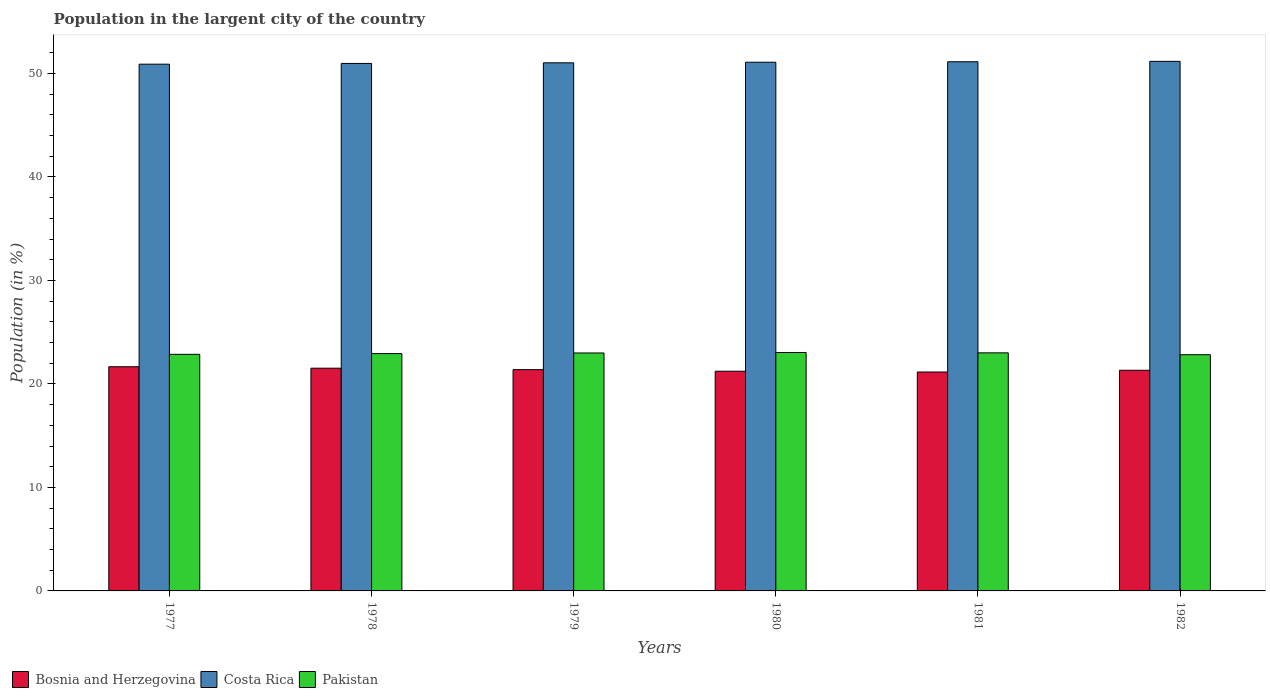How many groups of bars are there?
Your answer should be very brief. 6. Are the number of bars per tick equal to the number of legend labels?
Provide a short and direct response. Yes. Are the number of bars on each tick of the X-axis equal?
Make the answer very short. Yes. What is the label of the 4th group of bars from the left?
Your answer should be compact. 1980. In how many cases, is the number of bars for a given year not equal to the number of legend labels?
Offer a terse response. 0. What is the percentage of population in the largent city in Costa Rica in 1982?
Offer a terse response. 51.17. Across all years, what is the maximum percentage of population in the largent city in Bosnia and Herzegovina?
Keep it short and to the point. 21.66. Across all years, what is the minimum percentage of population in the largent city in Pakistan?
Provide a succinct answer. 22.82. In which year was the percentage of population in the largent city in Bosnia and Herzegovina maximum?
Make the answer very short. 1977. What is the total percentage of population in the largent city in Bosnia and Herzegovina in the graph?
Ensure brevity in your answer.  128.25. What is the difference between the percentage of population in the largent city in Pakistan in 1977 and that in 1981?
Offer a very short reply. -0.14. What is the difference between the percentage of population in the largent city in Pakistan in 1977 and the percentage of population in the largent city in Bosnia and Herzegovina in 1980?
Give a very brief answer. 1.63. What is the average percentage of population in the largent city in Pakistan per year?
Make the answer very short. 22.94. In the year 1978, what is the difference between the percentage of population in the largent city in Pakistan and percentage of population in the largent city in Costa Rica?
Offer a very short reply. -28.03. In how many years, is the percentage of population in the largent city in Pakistan greater than 20 %?
Ensure brevity in your answer.  6. What is the ratio of the percentage of population in the largent city in Costa Rica in 1977 to that in 1979?
Provide a succinct answer. 1. Is the difference between the percentage of population in the largent city in Pakistan in 1977 and 1981 greater than the difference between the percentage of population in the largent city in Costa Rica in 1977 and 1981?
Offer a terse response. Yes. What is the difference between the highest and the second highest percentage of population in the largent city in Costa Rica?
Keep it short and to the point. 0.04. What is the difference between the highest and the lowest percentage of population in the largent city in Pakistan?
Make the answer very short. 0.21. In how many years, is the percentage of population in the largent city in Pakistan greater than the average percentage of population in the largent city in Pakistan taken over all years?
Give a very brief answer. 3. Is the sum of the percentage of population in the largent city in Costa Rica in 1977 and 1981 greater than the maximum percentage of population in the largent city in Bosnia and Herzegovina across all years?
Your response must be concise. Yes. What does the 3rd bar from the left in 1977 represents?
Offer a very short reply. Pakistan. What does the 3rd bar from the right in 1980 represents?
Ensure brevity in your answer.  Bosnia and Herzegovina. How many bars are there?
Offer a terse response. 18. Are all the bars in the graph horizontal?
Your answer should be very brief. No. How many years are there in the graph?
Your answer should be very brief. 6. Are the values on the major ticks of Y-axis written in scientific E-notation?
Offer a very short reply. No. Does the graph contain any zero values?
Your response must be concise. No. Where does the legend appear in the graph?
Offer a terse response. Bottom left. What is the title of the graph?
Give a very brief answer. Population in the largent city of the country. What is the label or title of the X-axis?
Your answer should be very brief. Years. What is the label or title of the Y-axis?
Ensure brevity in your answer.  Population (in %). What is the Population (in %) in Bosnia and Herzegovina in 1977?
Your answer should be compact. 21.66. What is the Population (in %) of Costa Rica in 1977?
Offer a very short reply. 50.89. What is the Population (in %) in Pakistan in 1977?
Your response must be concise. 22.86. What is the Population (in %) in Bosnia and Herzegovina in 1978?
Provide a succinct answer. 21.52. What is the Population (in %) of Costa Rica in 1978?
Offer a very short reply. 50.96. What is the Population (in %) of Pakistan in 1978?
Offer a very short reply. 22.93. What is the Population (in %) in Bosnia and Herzegovina in 1979?
Your answer should be very brief. 21.38. What is the Population (in %) of Costa Rica in 1979?
Ensure brevity in your answer.  51.02. What is the Population (in %) in Pakistan in 1979?
Ensure brevity in your answer.  22.99. What is the Population (in %) of Bosnia and Herzegovina in 1980?
Offer a terse response. 21.23. What is the Population (in %) in Costa Rica in 1980?
Your answer should be compact. 51.08. What is the Population (in %) of Pakistan in 1980?
Your answer should be very brief. 23.04. What is the Population (in %) in Bosnia and Herzegovina in 1981?
Provide a short and direct response. 21.15. What is the Population (in %) of Costa Rica in 1981?
Offer a very short reply. 51.13. What is the Population (in %) of Pakistan in 1981?
Your answer should be very brief. 23. What is the Population (in %) in Bosnia and Herzegovina in 1982?
Your answer should be compact. 21.32. What is the Population (in %) of Costa Rica in 1982?
Provide a short and direct response. 51.17. What is the Population (in %) in Pakistan in 1982?
Give a very brief answer. 22.82. Across all years, what is the maximum Population (in %) in Bosnia and Herzegovina?
Keep it short and to the point. 21.66. Across all years, what is the maximum Population (in %) in Costa Rica?
Make the answer very short. 51.17. Across all years, what is the maximum Population (in %) in Pakistan?
Make the answer very short. 23.04. Across all years, what is the minimum Population (in %) of Bosnia and Herzegovina?
Keep it short and to the point. 21.15. Across all years, what is the minimum Population (in %) of Costa Rica?
Give a very brief answer. 50.89. Across all years, what is the minimum Population (in %) of Pakistan?
Give a very brief answer. 22.82. What is the total Population (in %) in Bosnia and Herzegovina in the graph?
Offer a very short reply. 128.25. What is the total Population (in %) of Costa Rica in the graph?
Provide a succinct answer. 306.25. What is the total Population (in %) in Pakistan in the graph?
Keep it short and to the point. 137.64. What is the difference between the Population (in %) of Bosnia and Herzegovina in 1977 and that in 1978?
Make the answer very short. 0.14. What is the difference between the Population (in %) in Costa Rica in 1977 and that in 1978?
Your answer should be very brief. -0.07. What is the difference between the Population (in %) of Pakistan in 1977 and that in 1978?
Ensure brevity in your answer.  -0.07. What is the difference between the Population (in %) in Bosnia and Herzegovina in 1977 and that in 1979?
Keep it short and to the point. 0.28. What is the difference between the Population (in %) in Costa Rica in 1977 and that in 1979?
Ensure brevity in your answer.  -0.13. What is the difference between the Population (in %) in Pakistan in 1977 and that in 1979?
Ensure brevity in your answer.  -0.13. What is the difference between the Population (in %) of Bosnia and Herzegovina in 1977 and that in 1980?
Your answer should be very brief. 0.43. What is the difference between the Population (in %) in Costa Rica in 1977 and that in 1980?
Ensure brevity in your answer.  -0.19. What is the difference between the Population (in %) in Pakistan in 1977 and that in 1980?
Keep it short and to the point. -0.18. What is the difference between the Population (in %) of Bosnia and Herzegovina in 1977 and that in 1981?
Provide a succinct answer. 0.51. What is the difference between the Population (in %) in Costa Rica in 1977 and that in 1981?
Offer a terse response. -0.23. What is the difference between the Population (in %) in Pakistan in 1977 and that in 1981?
Make the answer very short. -0.14. What is the difference between the Population (in %) of Bosnia and Herzegovina in 1977 and that in 1982?
Your response must be concise. 0.34. What is the difference between the Population (in %) in Costa Rica in 1977 and that in 1982?
Your answer should be very brief. -0.27. What is the difference between the Population (in %) of Pakistan in 1977 and that in 1982?
Offer a very short reply. 0.04. What is the difference between the Population (in %) in Bosnia and Herzegovina in 1978 and that in 1979?
Your answer should be very brief. 0.14. What is the difference between the Population (in %) in Costa Rica in 1978 and that in 1979?
Your answer should be very brief. -0.06. What is the difference between the Population (in %) of Pakistan in 1978 and that in 1979?
Provide a succinct answer. -0.06. What is the difference between the Population (in %) of Bosnia and Herzegovina in 1978 and that in 1980?
Make the answer very short. 0.29. What is the difference between the Population (in %) of Costa Rica in 1978 and that in 1980?
Ensure brevity in your answer.  -0.12. What is the difference between the Population (in %) of Pakistan in 1978 and that in 1980?
Ensure brevity in your answer.  -0.11. What is the difference between the Population (in %) of Bosnia and Herzegovina in 1978 and that in 1981?
Provide a succinct answer. 0.37. What is the difference between the Population (in %) of Costa Rica in 1978 and that in 1981?
Make the answer very short. -0.16. What is the difference between the Population (in %) in Pakistan in 1978 and that in 1981?
Your answer should be very brief. -0.07. What is the difference between the Population (in %) in Bosnia and Herzegovina in 1978 and that in 1982?
Your response must be concise. 0.2. What is the difference between the Population (in %) of Costa Rica in 1978 and that in 1982?
Provide a succinct answer. -0.2. What is the difference between the Population (in %) of Pakistan in 1978 and that in 1982?
Your answer should be compact. 0.11. What is the difference between the Population (in %) of Bosnia and Herzegovina in 1979 and that in 1980?
Provide a short and direct response. 0.15. What is the difference between the Population (in %) of Costa Rica in 1979 and that in 1980?
Offer a very short reply. -0.06. What is the difference between the Population (in %) in Pakistan in 1979 and that in 1980?
Your response must be concise. -0.05. What is the difference between the Population (in %) in Bosnia and Herzegovina in 1979 and that in 1981?
Your answer should be compact. 0.23. What is the difference between the Population (in %) of Costa Rica in 1979 and that in 1981?
Give a very brief answer. -0.1. What is the difference between the Population (in %) in Pakistan in 1979 and that in 1981?
Ensure brevity in your answer.  -0.01. What is the difference between the Population (in %) of Bosnia and Herzegovina in 1979 and that in 1982?
Ensure brevity in your answer.  0.06. What is the difference between the Population (in %) in Costa Rica in 1979 and that in 1982?
Provide a short and direct response. -0.14. What is the difference between the Population (in %) of Pakistan in 1979 and that in 1982?
Offer a very short reply. 0.17. What is the difference between the Population (in %) of Bosnia and Herzegovina in 1980 and that in 1981?
Your response must be concise. 0.07. What is the difference between the Population (in %) in Costa Rica in 1980 and that in 1981?
Your answer should be very brief. -0.05. What is the difference between the Population (in %) of Pakistan in 1980 and that in 1981?
Keep it short and to the point. 0.04. What is the difference between the Population (in %) in Bosnia and Herzegovina in 1980 and that in 1982?
Keep it short and to the point. -0.09. What is the difference between the Population (in %) in Costa Rica in 1980 and that in 1982?
Keep it short and to the point. -0.08. What is the difference between the Population (in %) in Pakistan in 1980 and that in 1982?
Offer a very short reply. 0.21. What is the difference between the Population (in %) in Bosnia and Herzegovina in 1981 and that in 1982?
Provide a short and direct response. -0.17. What is the difference between the Population (in %) of Costa Rica in 1981 and that in 1982?
Make the answer very short. -0.04. What is the difference between the Population (in %) of Pakistan in 1981 and that in 1982?
Provide a succinct answer. 0.18. What is the difference between the Population (in %) in Bosnia and Herzegovina in 1977 and the Population (in %) in Costa Rica in 1978?
Give a very brief answer. -29.3. What is the difference between the Population (in %) of Bosnia and Herzegovina in 1977 and the Population (in %) of Pakistan in 1978?
Give a very brief answer. -1.27. What is the difference between the Population (in %) in Costa Rica in 1977 and the Population (in %) in Pakistan in 1978?
Provide a short and direct response. 27.96. What is the difference between the Population (in %) in Bosnia and Herzegovina in 1977 and the Population (in %) in Costa Rica in 1979?
Provide a short and direct response. -29.36. What is the difference between the Population (in %) of Bosnia and Herzegovina in 1977 and the Population (in %) of Pakistan in 1979?
Ensure brevity in your answer.  -1.33. What is the difference between the Population (in %) of Costa Rica in 1977 and the Population (in %) of Pakistan in 1979?
Offer a very short reply. 27.9. What is the difference between the Population (in %) of Bosnia and Herzegovina in 1977 and the Population (in %) of Costa Rica in 1980?
Your answer should be very brief. -29.42. What is the difference between the Population (in %) of Bosnia and Herzegovina in 1977 and the Population (in %) of Pakistan in 1980?
Offer a terse response. -1.38. What is the difference between the Population (in %) in Costa Rica in 1977 and the Population (in %) in Pakistan in 1980?
Make the answer very short. 27.86. What is the difference between the Population (in %) in Bosnia and Herzegovina in 1977 and the Population (in %) in Costa Rica in 1981?
Provide a succinct answer. -29.47. What is the difference between the Population (in %) of Bosnia and Herzegovina in 1977 and the Population (in %) of Pakistan in 1981?
Your response must be concise. -1.34. What is the difference between the Population (in %) of Costa Rica in 1977 and the Population (in %) of Pakistan in 1981?
Offer a terse response. 27.89. What is the difference between the Population (in %) in Bosnia and Herzegovina in 1977 and the Population (in %) in Costa Rica in 1982?
Your response must be concise. -29.51. What is the difference between the Population (in %) in Bosnia and Herzegovina in 1977 and the Population (in %) in Pakistan in 1982?
Your answer should be compact. -1.16. What is the difference between the Population (in %) of Costa Rica in 1977 and the Population (in %) of Pakistan in 1982?
Your response must be concise. 28.07. What is the difference between the Population (in %) in Bosnia and Herzegovina in 1978 and the Population (in %) in Costa Rica in 1979?
Provide a succinct answer. -29.51. What is the difference between the Population (in %) in Bosnia and Herzegovina in 1978 and the Population (in %) in Pakistan in 1979?
Ensure brevity in your answer.  -1.47. What is the difference between the Population (in %) of Costa Rica in 1978 and the Population (in %) of Pakistan in 1979?
Your response must be concise. 27.97. What is the difference between the Population (in %) of Bosnia and Herzegovina in 1978 and the Population (in %) of Costa Rica in 1980?
Your response must be concise. -29.56. What is the difference between the Population (in %) in Bosnia and Herzegovina in 1978 and the Population (in %) in Pakistan in 1980?
Offer a very short reply. -1.52. What is the difference between the Population (in %) in Costa Rica in 1978 and the Population (in %) in Pakistan in 1980?
Provide a short and direct response. 27.93. What is the difference between the Population (in %) in Bosnia and Herzegovina in 1978 and the Population (in %) in Costa Rica in 1981?
Keep it short and to the point. -29.61. What is the difference between the Population (in %) in Bosnia and Herzegovina in 1978 and the Population (in %) in Pakistan in 1981?
Make the answer very short. -1.48. What is the difference between the Population (in %) in Costa Rica in 1978 and the Population (in %) in Pakistan in 1981?
Your response must be concise. 27.96. What is the difference between the Population (in %) of Bosnia and Herzegovina in 1978 and the Population (in %) of Costa Rica in 1982?
Your response must be concise. -29.65. What is the difference between the Population (in %) of Bosnia and Herzegovina in 1978 and the Population (in %) of Pakistan in 1982?
Your answer should be compact. -1.3. What is the difference between the Population (in %) of Costa Rica in 1978 and the Population (in %) of Pakistan in 1982?
Your answer should be compact. 28.14. What is the difference between the Population (in %) in Bosnia and Herzegovina in 1979 and the Population (in %) in Costa Rica in 1980?
Your answer should be compact. -29.7. What is the difference between the Population (in %) in Bosnia and Herzegovina in 1979 and the Population (in %) in Pakistan in 1980?
Make the answer very short. -1.66. What is the difference between the Population (in %) in Costa Rica in 1979 and the Population (in %) in Pakistan in 1980?
Your answer should be compact. 27.99. What is the difference between the Population (in %) in Bosnia and Herzegovina in 1979 and the Population (in %) in Costa Rica in 1981?
Provide a short and direct response. -29.75. What is the difference between the Population (in %) of Bosnia and Herzegovina in 1979 and the Population (in %) of Pakistan in 1981?
Keep it short and to the point. -1.62. What is the difference between the Population (in %) in Costa Rica in 1979 and the Population (in %) in Pakistan in 1981?
Offer a very short reply. 28.02. What is the difference between the Population (in %) in Bosnia and Herzegovina in 1979 and the Population (in %) in Costa Rica in 1982?
Offer a very short reply. -29.79. What is the difference between the Population (in %) of Bosnia and Herzegovina in 1979 and the Population (in %) of Pakistan in 1982?
Your answer should be compact. -1.44. What is the difference between the Population (in %) in Costa Rica in 1979 and the Population (in %) in Pakistan in 1982?
Keep it short and to the point. 28.2. What is the difference between the Population (in %) in Bosnia and Herzegovina in 1980 and the Population (in %) in Costa Rica in 1981?
Keep it short and to the point. -29.9. What is the difference between the Population (in %) in Bosnia and Herzegovina in 1980 and the Population (in %) in Pakistan in 1981?
Your answer should be compact. -1.78. What is the difference between the Population (in %) of Costa Rica in 1980 and the Population (in %) of Pakistan in 1981?
Your response must be concise. 28.08. What is the difference between the Population (in %) in Bosnia and Herzegovina in 1980 and the Population (in %) in Costa Rica in 1982?
Keep it short and to the point. -29.94. What is the difference between the Population (in %) of Bosnia and Herzegovina in 1980 and the Population (in %) of Pakistan in 1982?
Offer a very short reply. -1.6. What is the difference between the Population (in %) of Costa Rica in 1980 and the Population (in %) of Pakistan in 1982?
Give a very brief answer. 28.26. What is the difference between the Population (in %) in Bosnia and Herzegovina in 1981 and the Population (in %) in Costa Rica in 1982?
Provide a succinct answer. -30.01. What is the difference between the Population (in %) in Bosnia and Herzegovina in 1981 and the Population (in %) in Pakistan in 1982?
Provide a short and direct response. -1.67. What is the difference between the Population (in %) of Costa Rica in 1981 and the Population (in %) of Pakistan in 1982?
Your response must be concise. 28.3. What is the average Population (in %) in Bosnia and Herzegovina per year?
Provide a succinct answer. 21.38. What is the average Population (in %) in Costa Rica per year?
Provide a succinct answer. 51.04. What is the average Population (in %) in Pakistan per year?
Your response must be concise. 22.94. In the year 1977, what is the difference between the Population (in %) in Bosnia and Herzegovina and Population (in %) in Costa Rica?
Your response must be concise. -29.23. In the year 1977, what is the difference between the Population (in %) of Bosnia and Herzegovina and Population (in %) of Pakistan?
Provide a short and direct response. -1.2. In the year 1977, what is the difference between the Population (in %) of Costa Rica and Population (in %) of Pakistan?
Make the answer very short. 28.03. In the year 1978, what is the difference between the Population (in %) in Bosnia and Herzegovina and Population (in %) in Costa Rica?
Offer a terse response. -29.44. In the year 1978, what is the difference between the Population (in %) in Bosnia and Herzegovina and Population (in %) in Pakistan?
Keep it short and to the point. -1.41. In the year 1978, what is the difference between the Population (in %) in Costa Rica and Population (in %) in Pakistan?
Offer a terse response. 28.03. In the year 1979, what is the difference between the Population (in %) in Bosnia and Herzegovina and Population (in %) in Costa Rica?
Give a very brief answer. -29.65. In the year 1979, what is the difference between the Population (in %) of Bosnia and Herzegovina and Population (in %) of Pakistan?
Make the answer very short. -1.61. In the year 1979, what is the difference between the Population (in %) of Costa Rica and Population (in %) of Pakistan?
Ensure brevity in your answer.  28.03. In the year 1980, what is the difference between the Population (in %) in Bosnia and Herzegovina and Population (in %) in Costa Rica?
Your answer should be compact. -29.86. In the year 1980, what is the difference between the Population (in %) of Bosnia and Herzegovina and Population (in %) of Pakistan?
Provide a succinct answer. -1.81. In the year 1980, what is the difference between the Population (in %) of Costa Rica and Population (in %) of Pakistan?
Your response must be concise. 28.04. In the year 1981, what is the difference between the Population (in %) in Bosnia and Herzegovina and Population (in %) in Costa Rica?
Give a very brief answer. -29.98. In the year 1981, what is the difference between the Population (in %) of Bosnia and Herzegovina and Population (in %) of Pakistan?
Offer a terse response. -1.85. In the year 1981, what is the difference between the Population (in %) in Costa Rica and Population (in %) in Pakistan?
Ensure brevity in your answer.  28.12. In the year 1982, what is the difference between the Population (in %) of Bosnia and Herzegovina and Population (in %) of Costa Rica?
Your answer should be very brief. -29.85. In the year 1982, what is the difference between the Population (in %) in Bosnia and Herzegovina and Population (in %) in Pakistan?
Offer a terse response. -1.5. In the year 1982, what is the difference between the Population (in %) of Costa Rica and Population (in %) of Pakistan?
Your answer should be very brief. 28.34. What is the ratio of the Population (in %) of Bosnia and Herzegovina in 1977 to that in 1978?
Ensure brevity in your answer.  1.01. What is the ratio of the Population (in %) in Bosnia and Herzegovina in 1977 to that in 1979?
Ensure brevity in your answer.  1.01. What is the ratio of the Population (in %) in Costa Rica in 1977 to that in 1979?
Provide a succinct answer. 1. What is the ratio of the Population (in %) of Pakistan in 1977 to that in 1979?
Your answer should be very brief. 0.99. What is the ratio of the Population (in %) of Bosnia and Herzegovina in 1977 to that in 1980?
Ensure brevity in your answer.  1.02. What is the ratio of the Population (in %) in Costa Rica in 1977 to that in 1980?
Provide a short and direct response. 1. What is the ratio of the Population (in %) in Pakistan in 1977 to that in 1980?
Your answer should be very brief. 0.99. What is the ratio of the Population (in %) in Bosnia and Herzegovina in 1977 to that in 1981?
Offer a terse response. 1.02. What is the ratio of the Population (in %) in Pakistan in 1977 to that in 1981?
Give a very brief answer. 0.99. What is the ratio of the Population (in %) of Pakistan in 1977 to that in 1982?
Ensure brevity in your answer.  1. What is the ratio of the Population (in %) of Bosnia and Herzegovina in 1978 to that in 1979?
Offer a very short reply. 1.01. What is the ratio of the Population (in %) of Costa Rica in 1978 to that in 1979?
Provide a short and direct response. 1. What is the ratio of the Population (in %) in Bosnia and Herzegovina in 1978 to that in 1980?
Provide a succinct answer. 1.01. What is the ratio of the Population (in %) of Costa Rica in 1978 to that in 1980?
Ensure brevity in your answer.  1. What is the ratio of the Population (in %) of Pakistan in 1978 to that in 1980?
Keep it short and to the point. 1. What is the ratio of the Population (in %) of Bosnia and Herzegovina in 1978 to that in 1981?
Offer a terse response. 1.02. What is the ratio of the Population (in %) in Costa Rica in 1978 to that in 1981?
Your response must be concise. 1. What is the ratio of the Population (in %) in Bosnia and Herzegovina in 1978 to that in 1982?
Provide a short and direct response. 1.01. What is the ratio of the Population (in %) of Costa Rica in 1979 to that in 1980?
Offer a very short reply. 1. What is the ratio of the Population (in %) of Bosnia and Herzegovina in 1979 to that in 1981?
Provide a short and direct response. 1.01. What is the ratio of the Population (in %) in Bosnia and Herzegovina in 1979 to that in 1982?
Make the answer very short. 1. What is the ratio of the Population (in %) of Costa Rica in 1979 to that in 1982?
Keep it short and to the point. 1. What is the ratio of the Population (in %) of Pakistan in 1979 to that in 1982?
Offer a terse response. 1.01. What is the ratio of the Population (in %) of Costa Rica in 1980 to that in 1981?
Ensure brevity in your answer.  1. What is the ratio of the Population (in %) of Pakistan in 1980 to that in 1981?
Make the answer very short. 1. What is the ratio of the Population (in %) of Bosnia and Herzegovina in 1980 to that in 1982?
Offer a very short reply. 1. What is the ratio of the Population (in %) in Costa Rica in 1980 to that in 1982?
Your response must be concise. 1. What is the ratio of the Population (in %) in Pakistan in 1980 to that in 1982?
Provide a short and direct response. 1.01. What is the ratio of the Population (in %) of Costa Rica in 1981 to that in 1982?
Your response must be concise. 1. What is the ratio of the Population (in %) in Pakistan in 1981 to that in 1982?
Your answer should be very brief. 1.01. What is the difference between the highest and the second highest Population (in %) in Bosnia and Herzegovina?
Make the answer very short. 0.14. What is the difference between the highest and the second highest Population (in %) of Costa Rica?
Keep it short and to the point. 0.04. What is the difference between the highest and the second highest Population (in %) of Pakistan?
Offer a very short reply. 0.04. What is the difference between the highest and the lowest Population (in %) of Bosnia and Herzegovina?
Provide a succinct answer. 0.51. What is the difference between the highest and the lowest Population (in %) in Costa Rica?
Provide a short and direct response. 0.27. What is the difference between the highest and the lowest Population (in %) of Pakistan?
Ensure brevity in your answer.  0.21. 